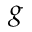Convert formula to latex. <formula><loc_0><loc_0><loc_500><loc_500>g</formula> 